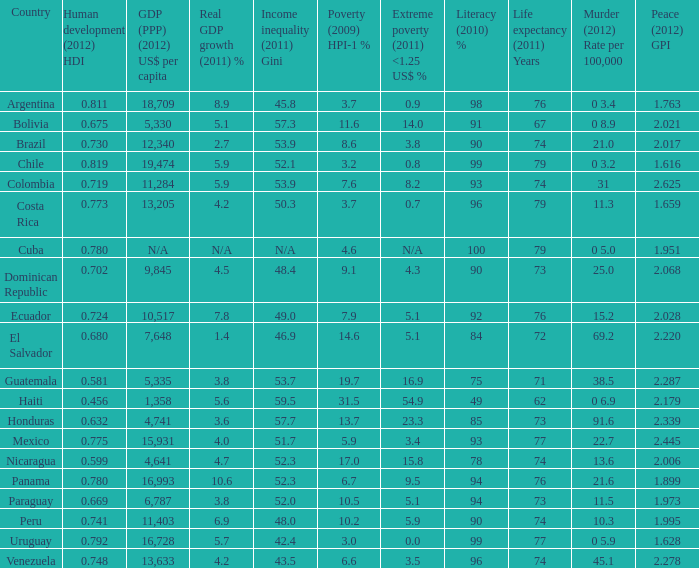25 us$ % amounts to 1 None. 